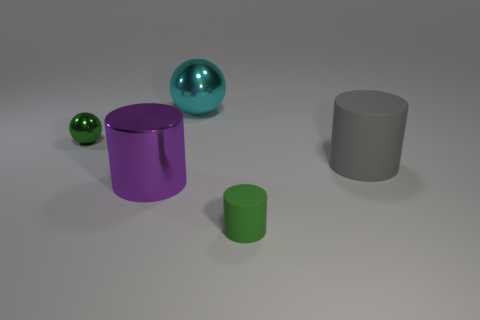How many other objects are there of the same size as the green sphere?
Provide a short and direct response. 1. Is the large sphere the same color as the large rubber thing?
Keep it short and to the point. No. There is a sphere that is in front of the metal object that is behind the small thing that is behind the green matte object; what is its color?
Your answer should be compact. Green. There is a sphere that is to the left of the large metallic thing that is in front of the green metal object; what number of small green objects are on the right side of it?
Give a very brief answer. 1. Is there any other thing that has the same color as the small rubber cylinder?
Give a very brief answer. Yes. There is a ball in front of the cyan metallic sphere; does it have the same size as the gray matte object?
Give a very brief answer. No. There is a green thing that is right of the tiny shiny thing; what number of large gray matte cylinders are in front of it?
Give a very brief answer. 0. There is a tiny green object that is on the left side of the tiny green thing that is in front of the large purple metal thing; are there any big purple objects that are behind it?
Offer a terse response. No. There is a green object that is the same shape as the big purple metallic thing; what is it made of?
Provide a short and direct response. Rubber. Is there any other thing that is made of the same material as the large cyan thing?
Provide a short and direct response. Yes. 